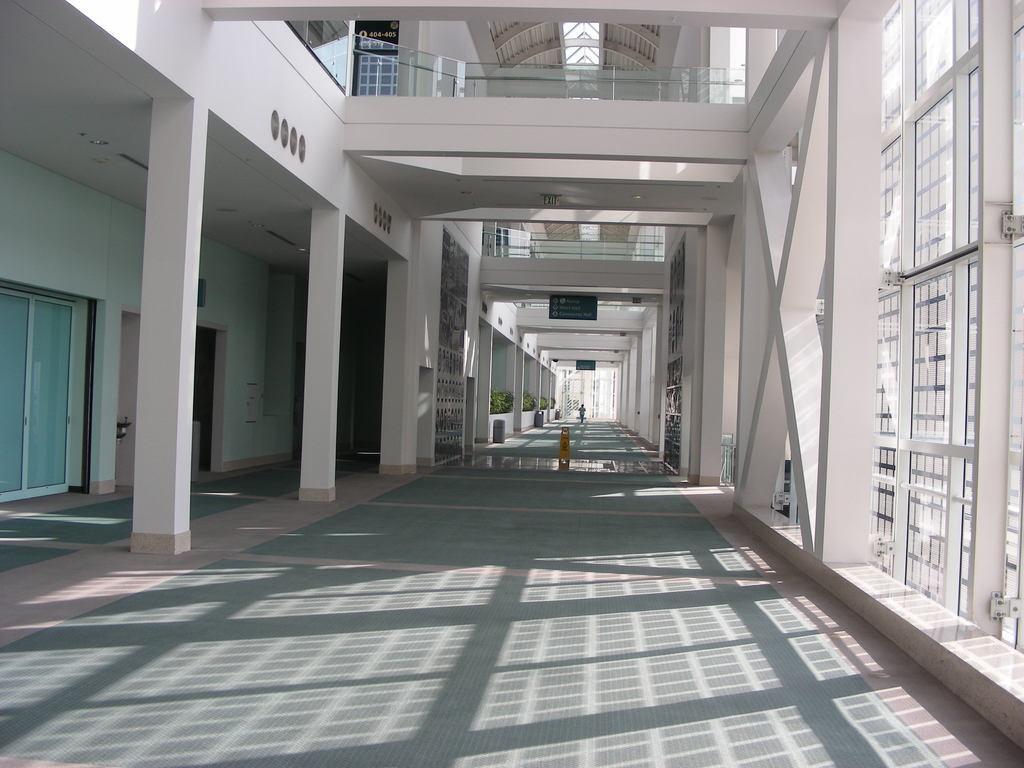Could you give a brief overview of what you see in this image? This image consists of a building. It looks like a corridor. To the left, there are room along doors and windows. And there are pillars. The walls are in white color. At the bottom, there is floor. 